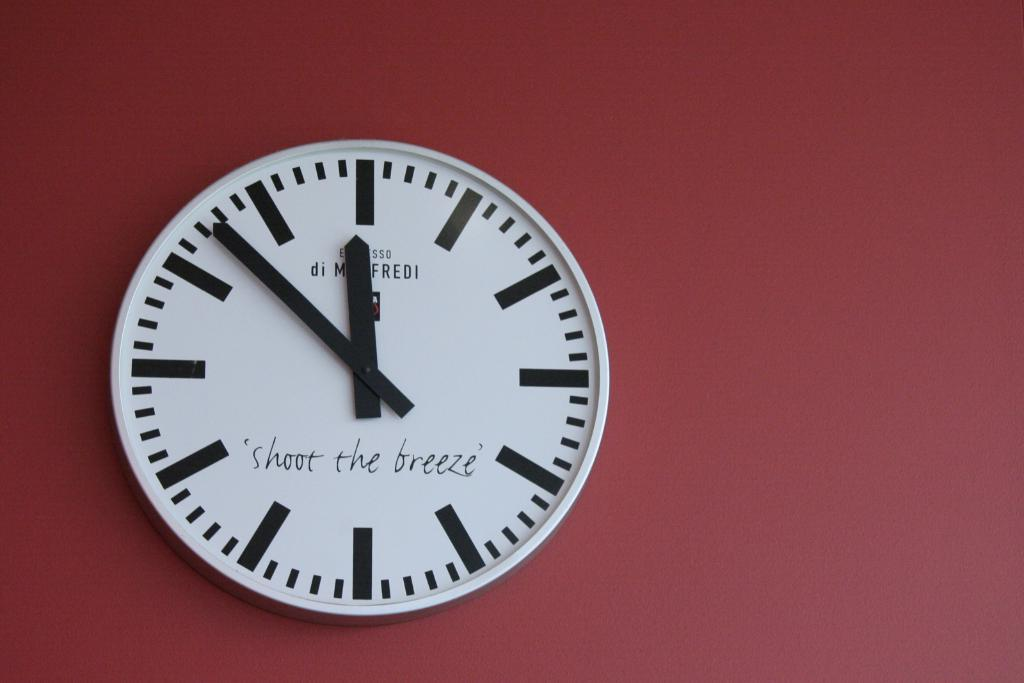<image>
Write a terse but informative summary of the picture. White face of a watch which says "shoot the breeze" on it. 